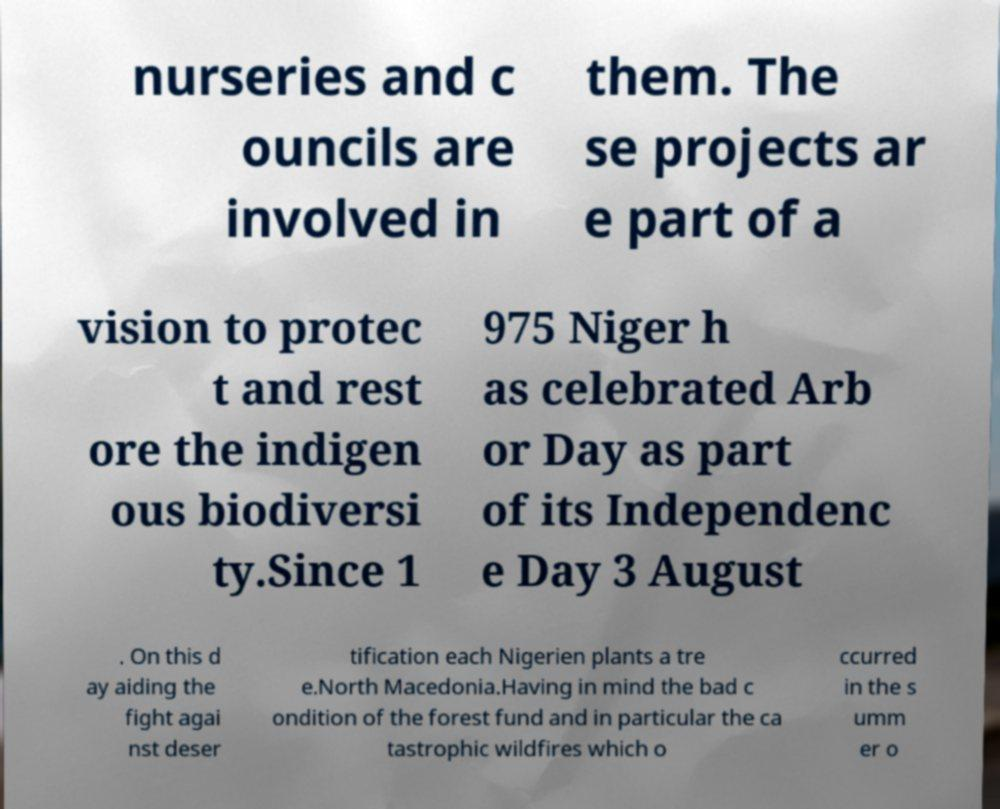Can you accurately transcribe the text from the provided image for me? nurseries and c ouncils are involved in them. The se projects ar e part of a vision to protec t and rest ore the indigen ous biodiversi ty.Since 1 975 Niger h as celebrated Arb or Day as part of its Independenc e Day 3 August . On this d ay aiding the fight agai nst deser tification each Nigerien plants a tre e.North Macedonia.Having in mind the bad c ondition of the forest fund and in particular the ca tastrophic wildfires which o ccurred in the s umm er o 